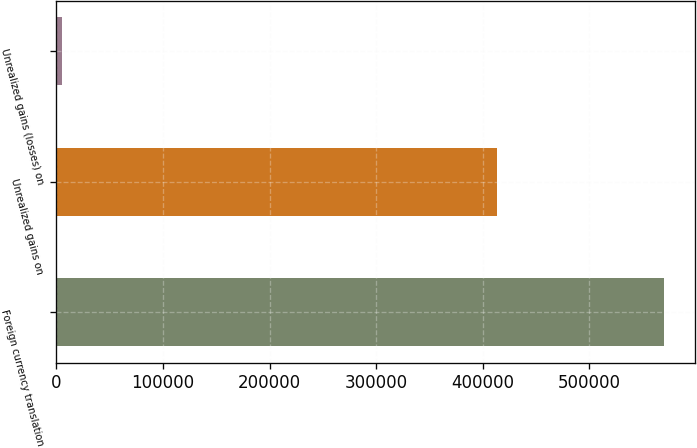<chart> <loc_0><loc_0><loc_500><loc_500><bar_chart><fcel>Foreign currency translation<fcel>Unrealized gains on<fcel>Unrealized gains (losses) on<nl><fcel>570440<fcel>413754<fcel>4821<nl></chart> 